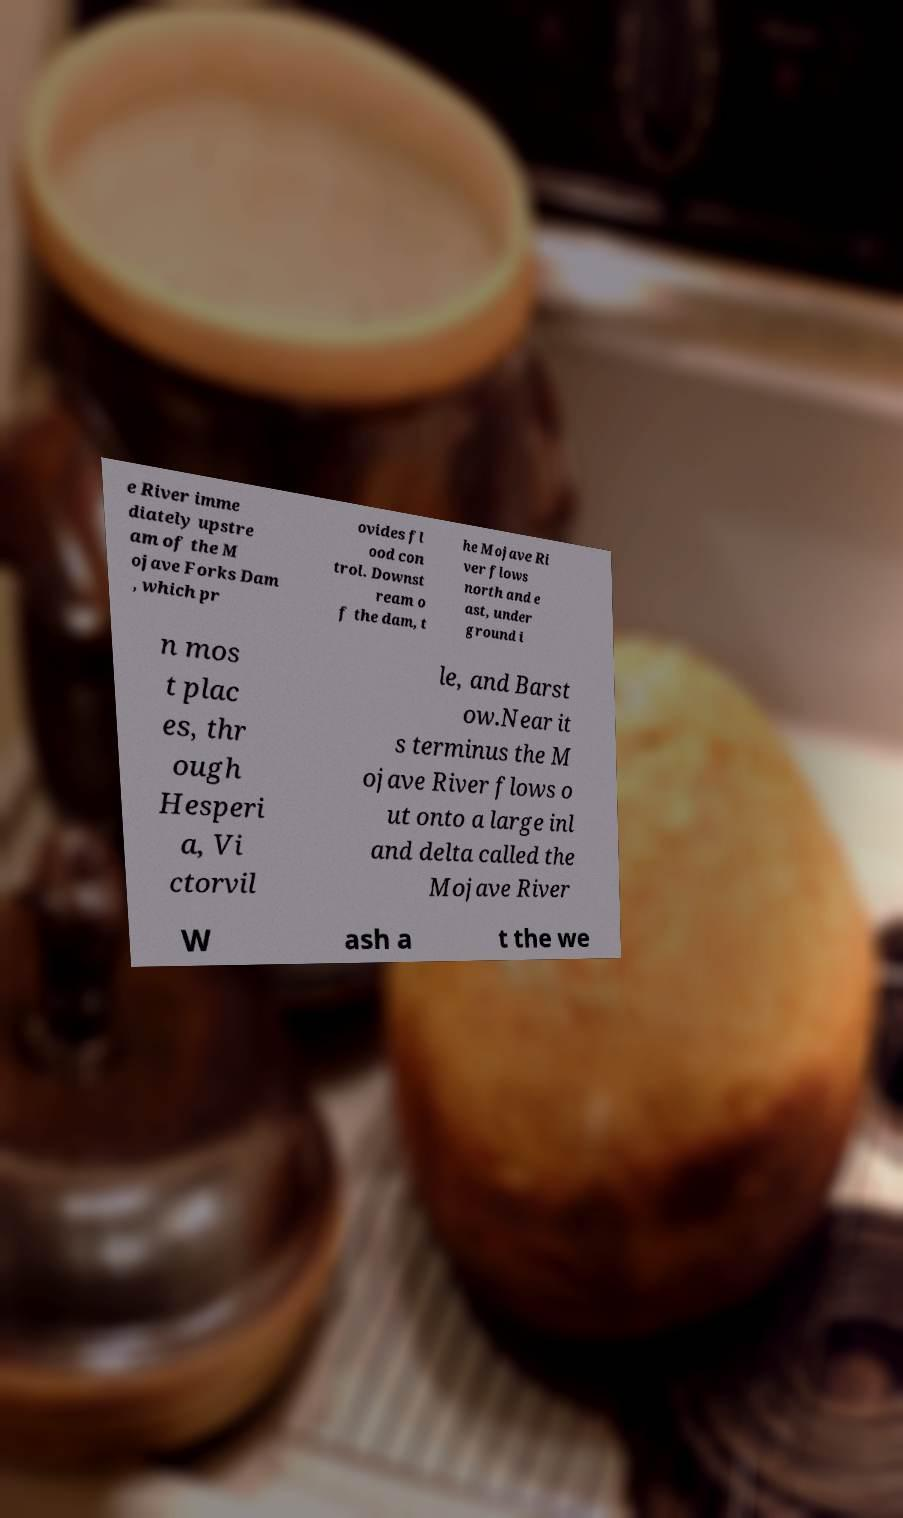Can you read and provide the text displayed in the image?This photo seems to have some interesting text. Can you extract and type it out for me? e River imme diately upstre am of the M ojave Forks Dam , which pr ovides fl ood con trol. Downst ream o f the dam, t he Mojave Ri ver flows north and e ast, under ground i n mos t plac es, thr ough Hesperi a, Vi ctorvil le, and Barst ow.Near it s terminus the M ojave River flows o ut onto a large inl and delta called the Mojave River W ash a t the we 